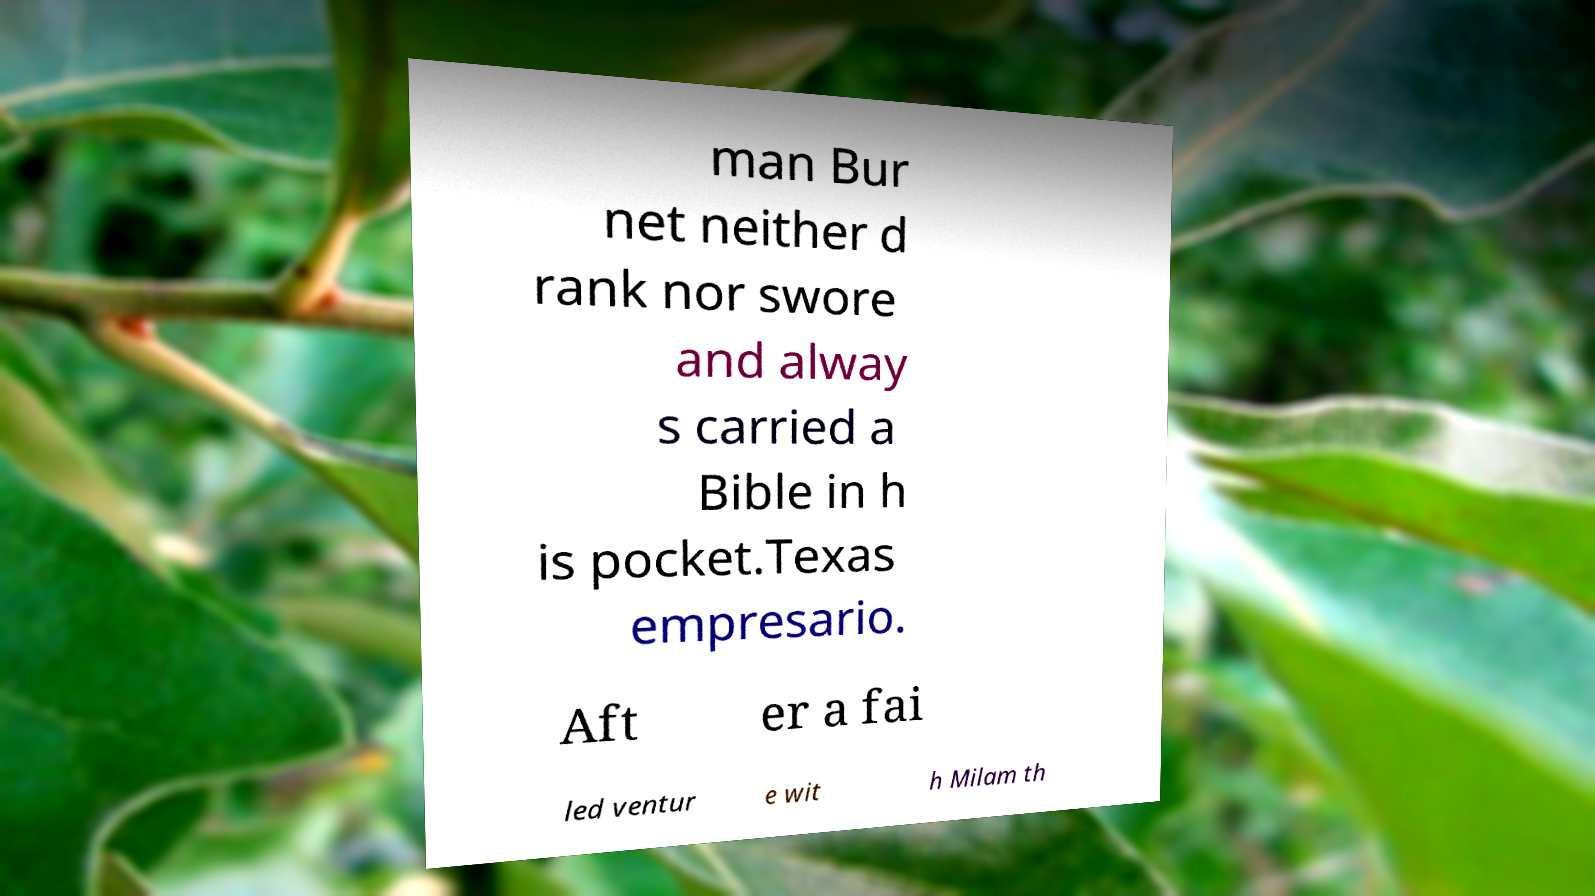Please read and relay the text visible in this image. What does it say? man Bur net neither d rank nor swore and alway s carried a Bible in h is pocket.Texas empresario. Aft er a fai led ventur e wit h Milam th 